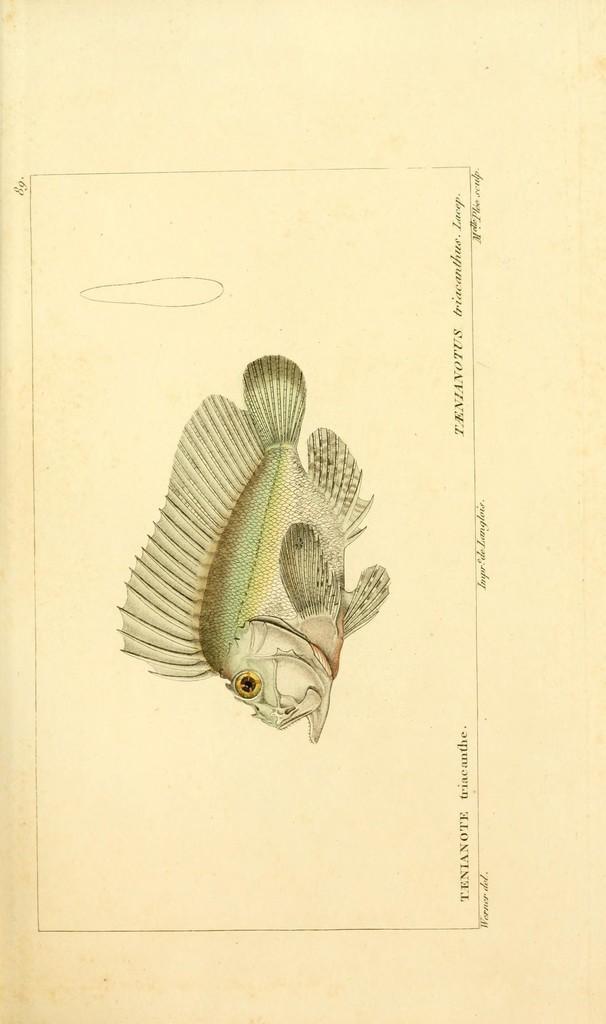Please provide a concise description of this image. In this image I see a paper on which there is a diagram of a fish and I see words written and I see 2 numbers over here. 